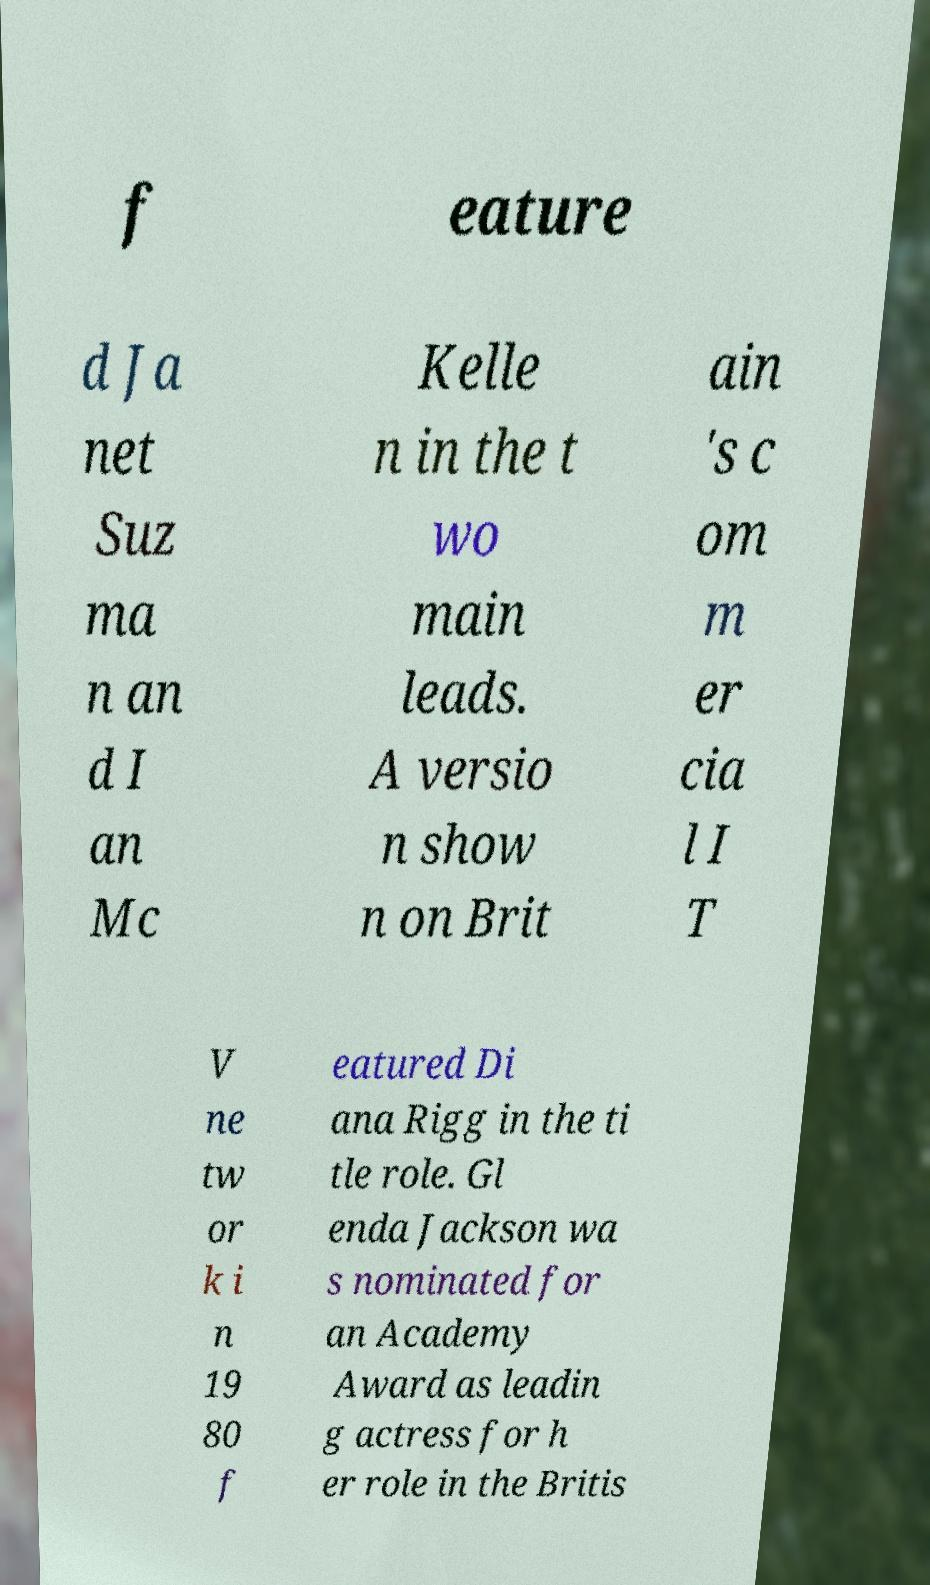Please identify and transcribe the text found in this image. f eature d Ja net Suz ma n an d I an Mc Kelle n in the t wo main leads. A versio n show n on Brit ain 's c om m er cia l I T V ne tw or k i n 19 80 f eatured Di ana Rigg in the ti tle role. Gl enda Jackson wa s nominated for an Academy Award as leadin g actress for h er role in the Britis 